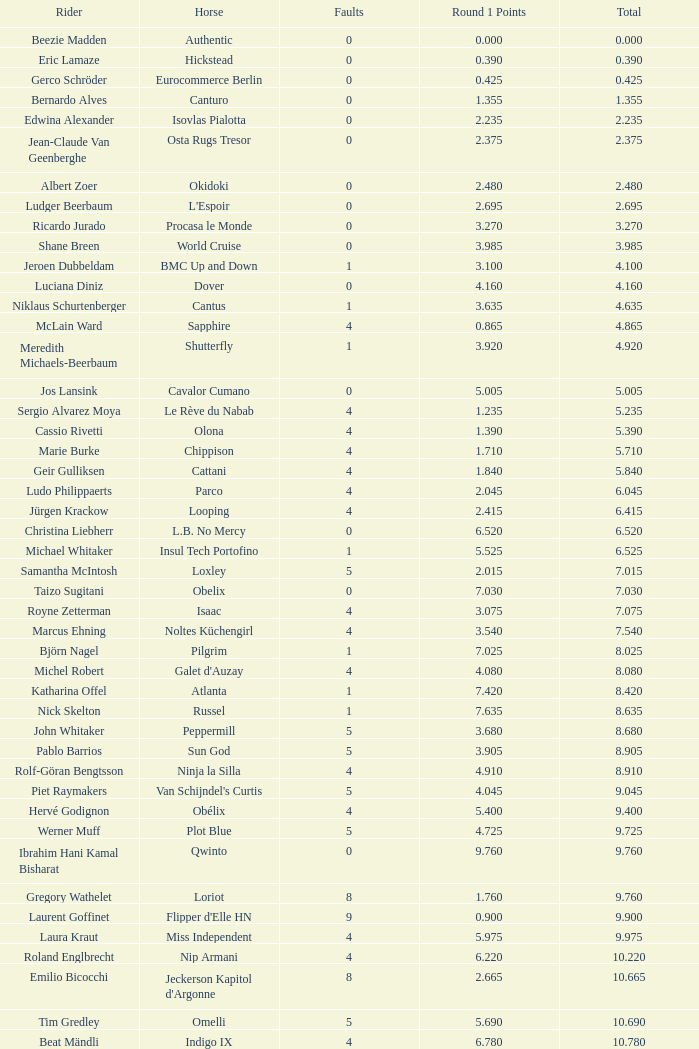Write the full table. {'header': ['Rider', 'Horse', 'Faults', 'Round 1 Points', 'Total'], 'rows': [['Beezie Madden', 'Authentic', '0', '0.000', '0.000'], ['Eric Lamaze', 'Hickstead', '0', '0.390', '0.390'], ['Gerco Schröder', 'Eurocommerce Berlin', '0', '0.425', '0.425'], ['Bernardo Alves', 'Canturo', '0', '1.355', '1.355'], ['Edwina Alexander', 'Isovlas Pialotta', '0', '2.235', '2.235'], ['Jean-Claude Van Geenberghe', 'Osta Rugs Tresor', '0', '2.375', '2.375'], ['Albert Zoer', 'Okidoki', '0', '2.480', '2.480'], ['Ludger Beerbaum', "L'Espoir", '0', '2.695', '2.695'], ['Ricardo Jurado', 'Procasa le Monde', '0', '3.270', '3.270'], ['Shane Breen', 'World Cruise', '0', '3.985', '3.985'], ['Jeroen Dubbeldam', 'BMC Up and Down', '1', '3.100', '4.100'], ['Luciana Diniz', 'Dover', '0', '4.160', '4.160'], ['Niklaus Schurtenberger', 'Cantus', '1', '3.635', '4.635'], ['McLain Ward', 'Sapphire', '4', '0.865', '4.865'], ['Meredith Michaels-Beerbaum', 'Shutterfly', '1', '3.920', '4.920'], ['Jos Lansink', 'Cavalor Cumano', '0', '5.005', '5.005'], ['Sergio Alvarez Moya', 'Le Rève du Nabab', '4', '1.235', '5.235'], ['Cassio Rivetti', 'Olona', '4', '1.390', '5.390'], ['Marie Burke', 'Chippison', '4', '1.710', '5.710'], ['Geir Gulliksen', 'Cattani', '4', '1.840', '5.840'], ['Ludo Philippaerts', 'Parco', '4', '2.045', '6.045'], ['Jürgen Krackow', 'Looping', '4', '2.415', '6.415'], ['Christina Liebherr', 'L.B. No Mercy', '0', '6.520', '6.520'], ['Michael Whitaker', 'Insul Tech Portofino', '1', '5.525', '6.525'], ['Samantha McIntosh', 'Loxley', '5', '2.015', '7.015'], ['Taizo Sugitani', 'Obelix', '0', '7.030', '7.030'], ['Royne Zetterman', 'Isaac', '4', '3.075', '7.075'], ['Marcus Ehning', 'Noltes Küchengirl', '4', '3.540', '7.540'], ['Björn Nagel', 'Pilgrim', '1', '7.025', '8.025'], ['Michel Robert', "Galet d'Auzay", '4', '4.080', '8.080'], ['Katharina Offel', 'Atlanta', '1', '7.420', '8.420'], ['Nick Skelton', 'Russel', '1', '7.635', '8.635'], ['John Whitaker', 'Peppermill', '5', '3.680', '8.680'], ['Pablo Barrios', 'Sun God', '5', '3.905', '8.905'], ['Rolf-Göran Bengtsson', 'Ninja la Silla', '4', '4.910', '8.910'], ['Piet Raymakers', "Van Schijndel's Curtis", '5', '4.045', '9.045'], ['Hervé Godignon', 'Obélix', '4', '5.400', '9.400'], ['Werner Muff', 'Plot Blue', '5', '4.725', '9.725'], ['Ibrahim Hani Kamal Bisharat', 'Qwinto', '0', '9.760', '9.760'], ['Gregory Wathelet', 'Loriot', '8', '1.760', '9.760'], ['Laurent Goffinet', "Flipper d'Elle HN", '9', '0.900', '9.900'], ['Laura Kraut', 'Miss Independent', '4', '5.975', '9.975'], ['Roland Englbrecht', 'Nip Armani', '4', '6.220', '10.220'], ['Emilio Bicocchi', "Jeckerson Kapitol d'Argonne", '8', '2.665', '10.665'], ['Tim Gredley', 'Omelli', '5', '5.690', '10.690'], ['Beat Mändli', 'Indigo IX', '4', '6.780', '10.780'], ['Christian Ahlmann', 'Cöster', '8', '4.000', '12.000'], ['Tina Lund', 'Carola', '9', '3.610', '12.610'], ['Max Amaya', 'Church Road', '8', '4.790', '12.790'], ['Álvaro Alfonso de Miranda Neto', 'Nike', '9', '4.235', '13.235'], ['Jesus Garmendia Echeverria', 'Maddock', '8', '5.335', '13.335'], ['Carlos Lopez', 'Instit', '10', '3.620', '13.620'], ['Juan Carlos García', 'Loro Piana Albin III', '5', '9.020', '14.020'], ['Cameron Hanley', 'Siec Hippica Kerman', '9', '5.375', '14.375'], ['Ricardo Kierkegaard', 'Rey Z', '8', '6.805', '14.805'], ['Jill Henselwood', 'Special Ed', '9', '6.165', '15.165'], ['Margie Engle', "Hidden Creek's Quervo Gold", '4', '12.065', '16.065'], ['Judy-Ann Melchoir', 'Grande Dame Z', '9', '7.310', '16.310'], ['Maria Gretzer', 'Spender S', '9', '7.385', '16.385'], ['Billy Twomey', 'Luidam', '9', '7.615', '16.615'], ['Federico Fernandez', 'Bohemio', '8', '9.610', '17.610'], ['Jonella Ligresti', 'Quinta 27', '6', '12.365', '18.365'], ['Ian Millar', 'In Style', '9', '9.370', '18.370'], ['Mikael Forsten', "BMC's Skybreaker", '12', '6.435', '18.435'], ['Sebastian Numminen', 'Sails Away', '13', '5.455', '18.455'], ['Stefan Eder', 'Cartier PSG', '12', '6.535', '18.535'], ['Dirk Demeersman', 'Clinton', '16', '2.755', '18.755'], ['Antonis Petris', 'Gredo la Daviere', '13', '6.300', '19.300'], ['Gunnar Klettenberg', 'Novesta', '9', '10.620', '19.620'], ['Syed Omar Almohdzar', 'Lui', '10', '9.820', '19.820'], ['Tony Andre Hansen', 'Camiro', '13', '7.245', '20.245'], ['Manuel Fernandez Saro', 'Quin Chin', '13', '7.465', '20.465'], ['James Wingrave', 'Agropoint Calira', '14', '6.855', '20.855'], ['Rod Brown', 'Mr. Burns', '9', '12.300', '21.300'], ['Jiri Papousek', 'La Manche T', '13', '8.440', '21.440'], ['Marcela Lobo', 'Joskin', '14', '7.600', '21.600'], ['Yuko Itakura', 'Portvliet', '9', '12.655', '21.655'], ['Zsolt Pirik', 'Havanna', '9', '13.050', '22.050'], ['Fabrice Lyon', 'Jasmine du Perron', '11', '12.760', '23.760'], ['Florian Angot', 'First de Launay', '16', '8.055', '24.055'], ['Peter McMahon', 'Kolora Stud Genoa', '9', '15.195', '24.195'], ['Giuseppe Rolli', 'Jericho de la Vie', '17', '7.910', '24.910'], ['Alberto Michan', 'Chinobampo Lavita', '13', '12.330', '25.330'], ['Hanno Ellermann', 'Poncorde', '17', '8.600', '25.600'], ['Antonio Portela Carneiro', 'Echo de Lessay', '18', '8.565', '26.565'], ['Gerfried Puck', '11th Bleeker', '21', '6.405', '27.405'], ['H.H. Prince Faisal Al-Shalan', 'Uthago', '18', '10.205', '28.205'], ['Vladimir Beletskiy', 'Rezonanz', '21', '7.725', '28.725'], ['Noora Pentti', 'Evli Cagliostro', '17', '12.455', '29.455'], ['Mohammed Al-Kumaiti', 'Al-Mutawakel', '17', '12.490', '29.490'], ['Guillermo Obligado', 'Carlson', '18', '11.545', '29.545'], ['Kamal Bahamdan', 'Campus', '17', '13.190', '30.190'], ['Veronika Macanova', 'Pompos', '13', '18.185', '31.185'], ['Vladimir Panchenko', 'Lanteno', '17', '14.460', '31.460'], ['Jose Larocca', 'Svante', '25', '8.190', '33.190'], ['Abdullah Al-Sharbatly', 'Hugo Gesmeray', '25', '8.585', '33.585'], ['Eiken Sato', 'Cayak DH', '17', '17.960', '34.960'], ['Gennadiy Gashiboyazov', 'Papirus', '28', '8.685', '36.685'], ['Karim El-Zoghby', 'Baragway', '21', '16.360', '37.360'], ['Ondrej Nagr', 'Atlas', '19', '19.865', '38.865'], ['Roger Hessen', 'Quito', '23', '17.410', '40.410'], ['Zdenek Zila', 'Pinot Grigio', '15', '26.035', '41.035'], ['Rene Lopez', 'Isky', '30', '11.675', '41.675'], ['Emmanouela Athanassiades', 'Rimini Z', '18', '24.380', '42.380'], ['Jamie Kermond', 'Stylish King', '21', '46.035', '67.035'], ['Malin Baryard-Johnsson', 'Butterfly Flip', '29', '46.035', '75.035'], ['Manuel Torres', 'Chambacunero', 'Fall', 'Fall', '5.470'], ['Krzyszlof Ludwiczak', 'HOF Schretstakens Quamiro', 'Eliminated', 'Eliminated', '7.460'], ['Grant Wilson', 'Up and Down Cellebroedersbos', 'Refusal', 'Refusal', '14.835'], ['Chris Pratt', 'Rivendell', 'Fall', 'Fall', '15.220'], ['Ariana Azcarraga', 'Sambo', 'Eliminated', 'Eliminated', '15.945'], ['Jose Alfredo Hernandez Ortega', 'Semtex P', 'Eliminated', 'Eliminated', '46.035'], ['H.R.H. Prince Abdullah Al-Soud', 'Allah Jabek', 'Retired', 'Retired', '46.035']]} Tell me the most total for horse of carlson 29.545. 